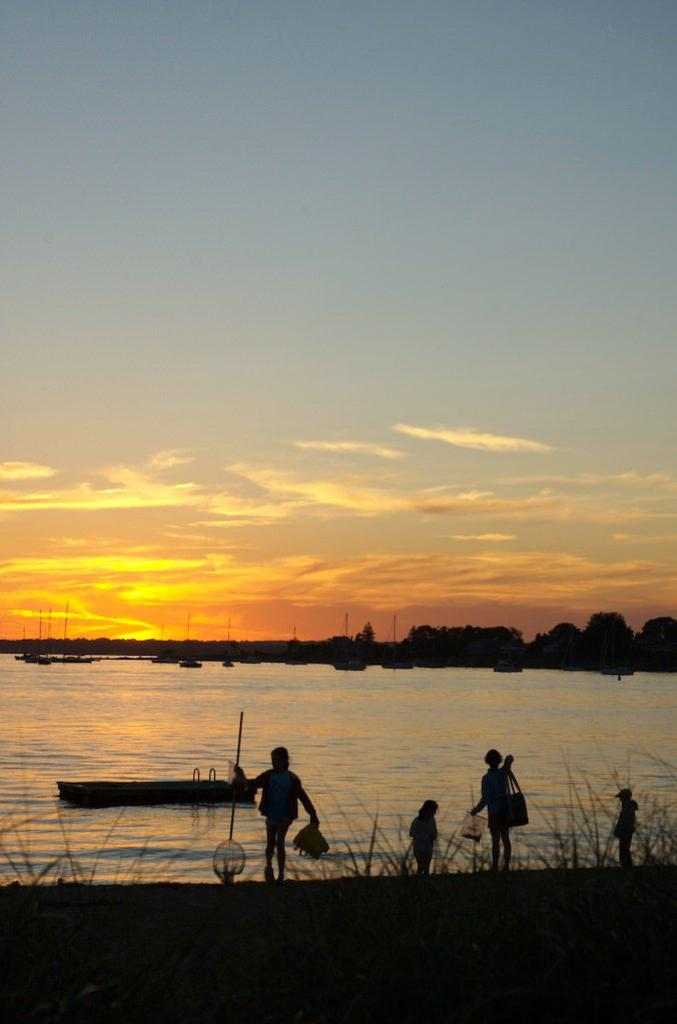What is the main feature of the landscape in the picture? There is a lake in the picture. What are the people near the lake doing? There are people standing near the lake. Can you describe the age group of the individuals in the picture? There are children in the picture. What can be seen in the background of the picture? There are trees in the background of the picture. How would you describe the weather based on the image? The sky is clear in the picture, suggesting good weather. What type of winter sport is being played on the lake in the image? There is no indication of any winter sports or activities taking place on the lake in the image. 